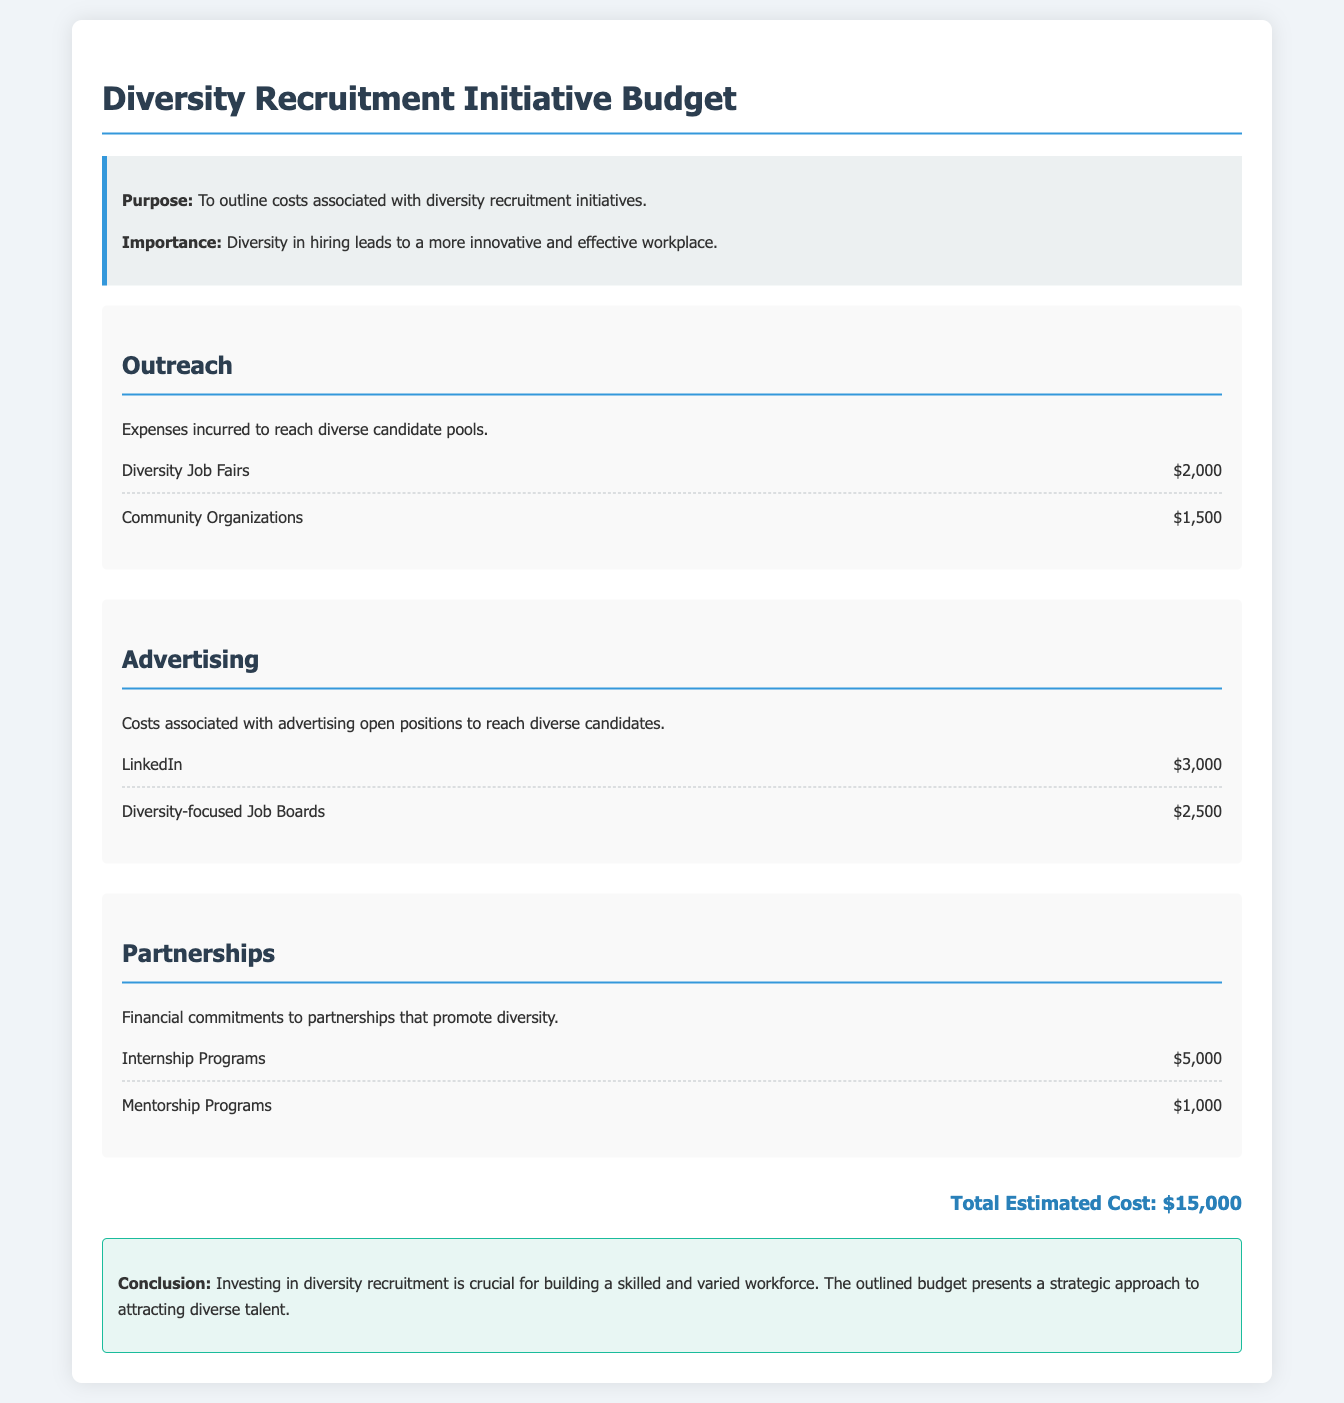What is the total estimated cost? The total estimated cost is presented at the end of the document as the cumulative amount of all expenditures listed.
Answer: $15,000 How much is allocated for Diversity Job Fairs? The cost for Diversity Job Fairs is specifically stated in the outreach section of the document.
Answer: $2,000 What is the expenditure for internship programs? The amount for internship programs is listed under the partnerships category in the budget.
Answer: $5,000 Which platform has a higher advertising cost, LinkedIn or diversity-focused job boards? This question requires comparison of the specific expenditure amounts for both advertising platforms given in the document.
Answer: LinkedIn How much is spent on community organizations? The document specifies a amount dedicated to community organizations under the outreach section.
Answer: $1,500 What are the two types of partnerships mentioned in the budget? The types of partnerships are explicitly mentioned in the partnerships section of the document.
Answer: Internship Programs and Mentorship Programs What purpose does the diversity recruitment initiative serve? The document outlines the purpose at the beginning, describing its overall goal.
Answer: To outline costs associated with diversity recruitment initiatives How much is spent on advertising to diversity-focused job boards? The specific expenditure for advertising to diversity-focused job boards is detailed in the advertising section.
Answer: $2,500 